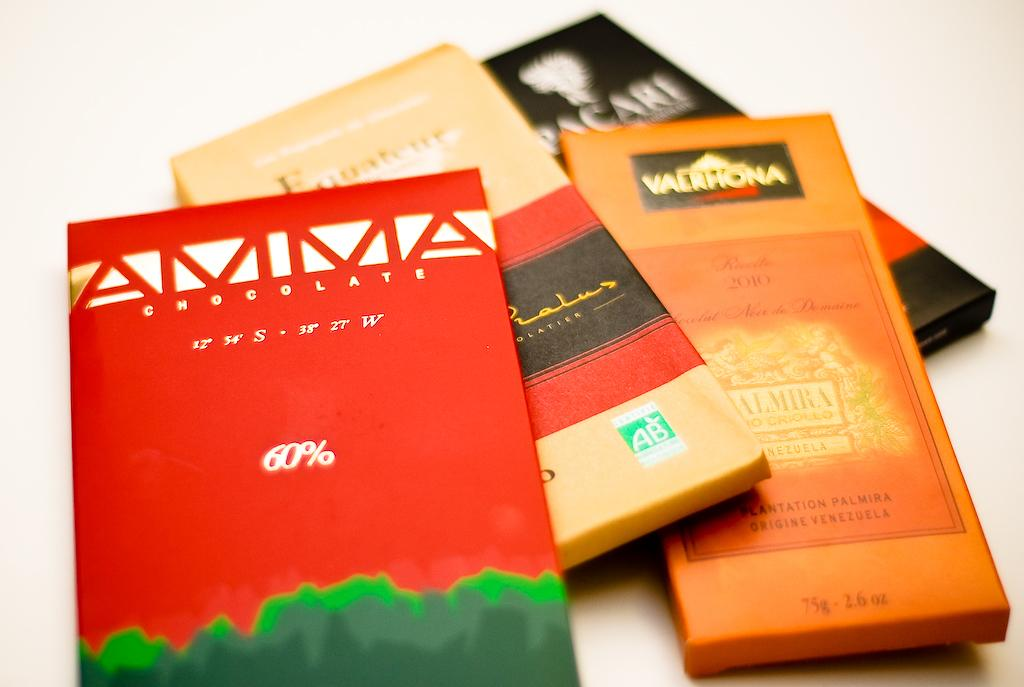<image>
Share a concise interpretation of the image provided. A bunch of chocolates with the front one by the brand AMMA. 